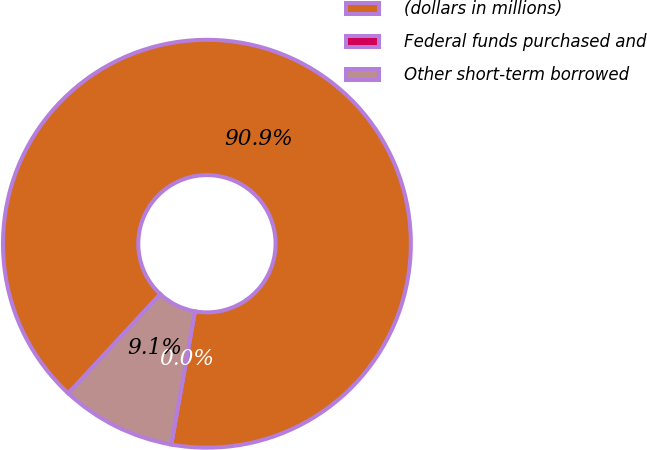Convert chart to OTSL. <chart><loc_0><loc_0><loc_500><loc_500><pie_chart><fcel>(dollars in millions)<fcel>Federal funds purchased and<fcel>Other short-term borrowed<nl><fcel>90.9%<fcel>0.0%<fcel>9.09%<nl></chart> 